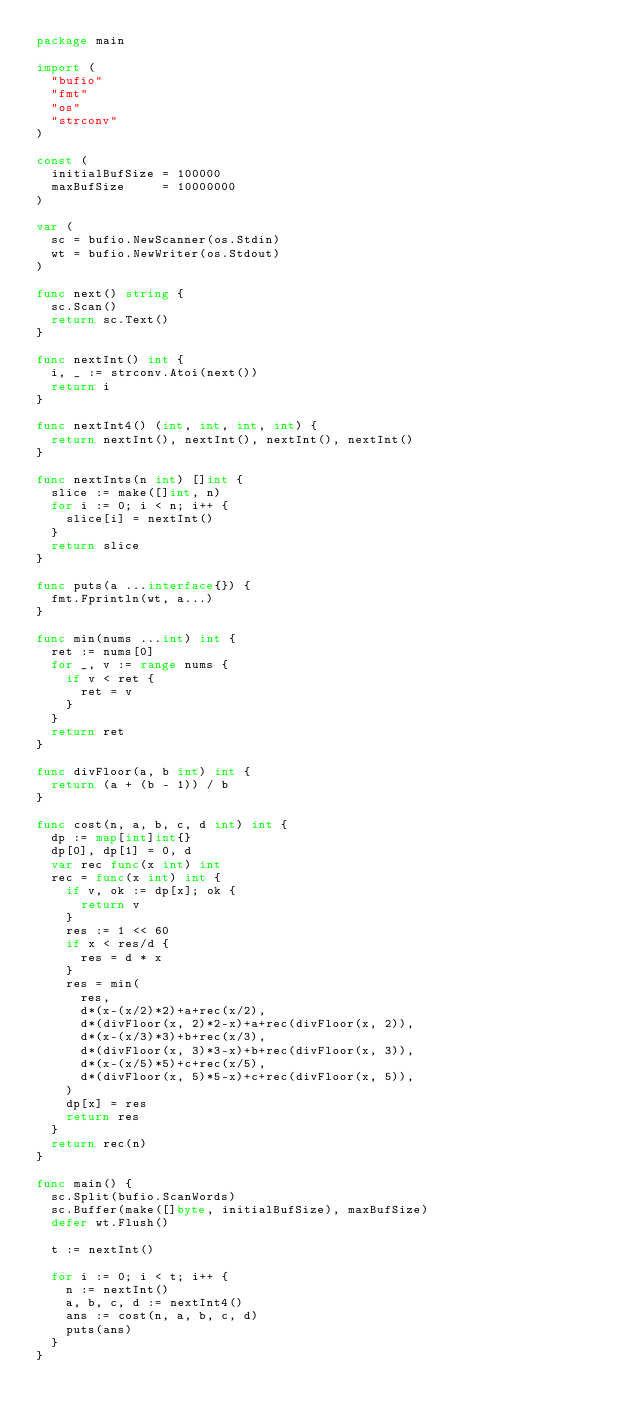Convert code to text. <code><loc_0><loc_0><loc_500><loc_500><_Go_>package main

import (
	"bufio"
	"fmt"
	"os"
	"strconv"
)

const (
	initialBufSize = 100000
	maxBufSize     = 10000000
)

var (
	sc = bufio.NewScanner(os.Stdin)
	wt = bufio.NewWriter(os.Stdout)
)

func next() string {
	sc.Scan()
	return sc.Text()
}

func nextInt() int {
	i, _ := strconv.Atoi(next())
	return i
}

func nextInt4() (int, int, int, int) {
	return nextInt(), nextInt(), nextInt(), nextInt()
}

func nextInts(n int) []int {
	slice := make([]int, n)
	for i := 0; i < n; i++ {
		slice[i] = nextInt()
	}
	return slice
}

func puts(a ...interface{}) {
	fmt.Fprintln(wt, a...)
}

func min(nums ...int) int {
	ret := nums[0]
	for _, v := range nums {
		if v < ret {
			ret = v
		}
	}
	return ret
}

func divFloor(a, b int) int {
	return (a + (b - 1)) / b
}

func cost(n, a, b, c, d int) int {
	dp := map[int]int{}
	dp[0], dp[1] = 0, d
	var rec func(x int) int
	rec = func(x int) int {
		if v, ok := dp[x]; ok {
			return v
		}
		res := 1 << 60
		if x < res/d {
			res = d * x
		}
		res = min(
			res,
			d*(x-(x/2)*2)+a+rec(x/2),
			d*(divFloor(x, 2)*2-x)+a+rec(divFloor(x, 2)),
			d*(x-(x/3)*3)+b+rec(x/3),
			d*(divFloor(x, 3)*3-x)+b+rec(divFloor(x, 3)),
			d*(x-(x/5)*5)+c+rec(x/5),
			d*(divFloor(x, 5)*5-x)+c+rec(divFloor(x, 5)),
		)
		dp[x] = res
		return res
	}
	return rec(n)
}

func main() {
	sc.Split(bufio.ScanWords)
	sc.Buffer(make([]byte, initialBufSize), maxBufSize)
	defer wt.Flush()

	t := nextInt()

	for i := 0; i < t; i++ {
		n := nextInt()
		a, b, c, d := nextInt4()
		ans := cost(n, a, b, c, d)
		puts(ans)
	}
}
</code> 